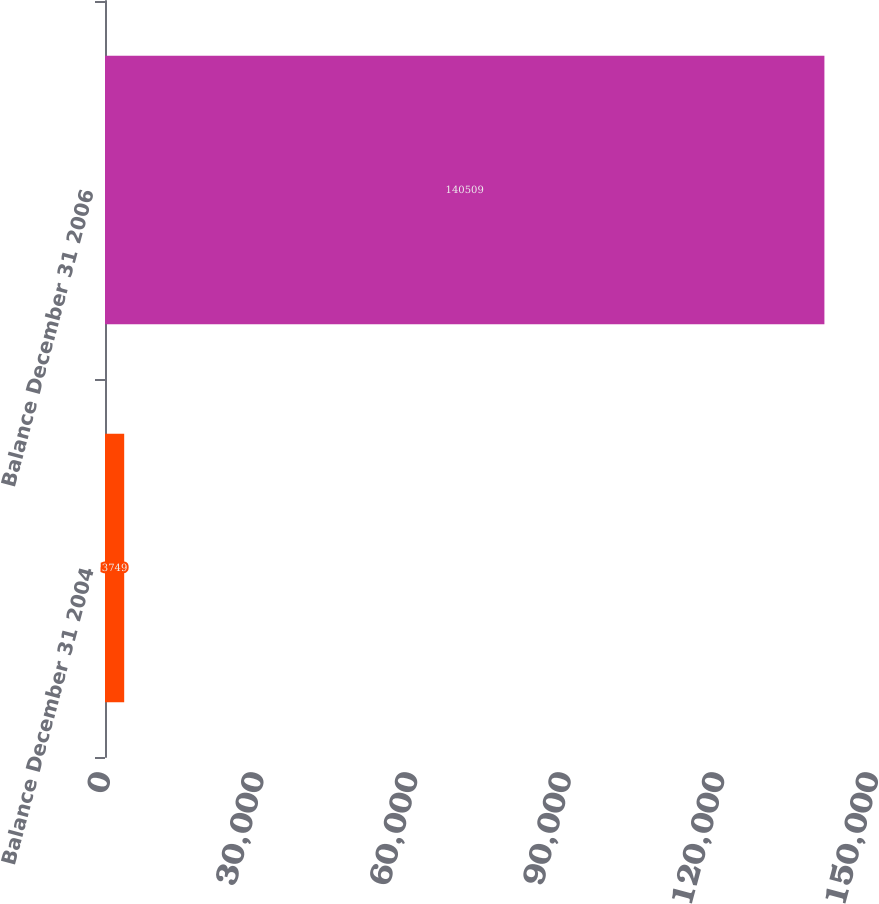<chart> <loc_0><loc_0><loc_500><loc_500><bar_chart><fcel>Balance December 31 2004<fcel>Balance December 31 2006<nl><fcel>3749<fcel>140509<nl></chart> 